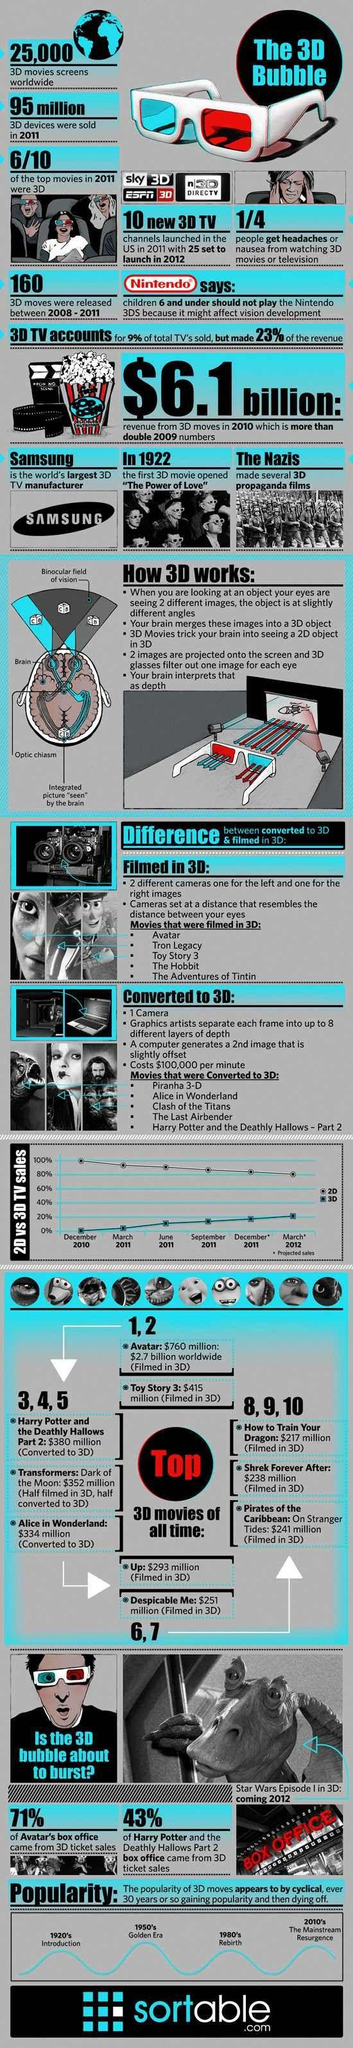Identify some key points in this picture. In 2011, only four of the top movies that were released were not in 3D format. In 2010, the sale of 3D televisions was the least. 5 movies listed in the infographic are filmed in 3D. Toy Story 3 is the second top 3D movie. In March 2012, a significant number of 3D televisions were sold. 